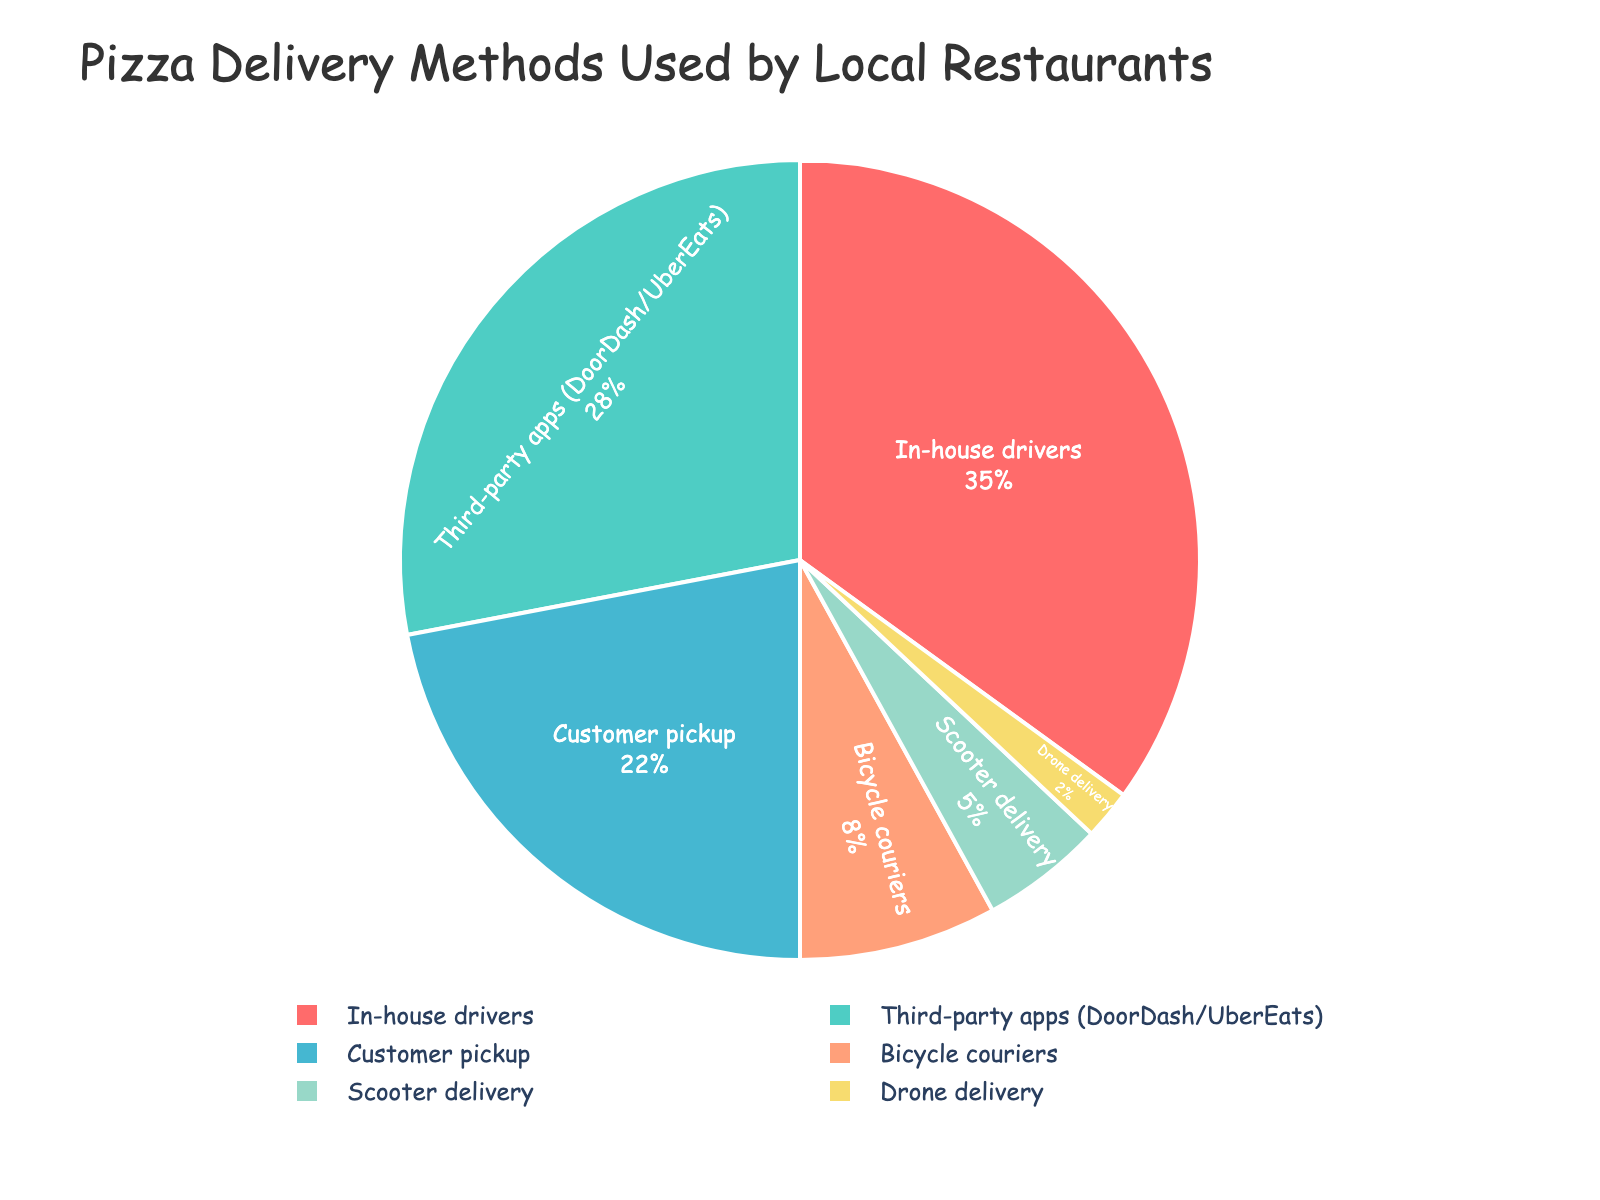What's the most common pizza delivery method? The pie chart shows that "In-house drivers" have the largest slice of the pie, indicating they are the most commonly used delivery method.
Answer: In-house drivers Which delivery method is used more: Bicycle couriers or Scooter delivery? The chart shows that Bicycle couriers make up 8% while Scooter delivery makes up 5% of the delivery methods. By comparing these percentages, it's clear that Bicycle couriers are used more.
Answer: Bicycle couriers What's the total percentage of delivery methods that do not involve motor vehicles? Non-motor vehicle methods include Bicycle couriers (8%), Customer pickup (22%), and Drone delivery (2%). Adding these percentages: 8 + 22 + 2 = 32.
Answer: 32% How much more popular are third-party apps compared to scooter delivery? Third-party apps make up 28% while Scooter delivery accounts for 5%. To find how much more popular third-party apps are, subtract these values: 28 - 5 = 23.
Answer: 23% What delivery method is represented by the yellow slice? The yellow slice of the pie chart corresponds to Drone delivery, which occupies 2% of the chart.
Answer: Drone delivery Which methods together make up more than half (over 50%) of the delivery methods? Adding the percentages of the most common methods: In-house drivers (35%) and Third-party apps (28%) results in 35 + 28 = 63, which is over 50%.
Answer: In-house drivers and Third-party apps What's the difference in percentage between the least common and the most common delivery methods? The least common delivery method is Drone delivery (2%), and the most common is In-house drivers (35%). The difference is 35 - 2 = 33.
Answer: 33% How many delivery methods have less than 10% usage? The chart shows that Bicycle couriers (8%), Scooter delivery (5%), and Drone delivery (2%) each have less than 10% usage. Counting these methods, there are 3.
Answer: 3 By what percentage is Customer pickup less popular than In-house drivers? Customer pickup is 22%, and In-house drivers are 35%. Subtracting these: 35 - 22 = 13.
Answer: 13% What percentage of restaurants use methods other than In-house drivers, Third-party apps, and Customer pickup? Methods other than the top three are Bicycle couriers (8%), Scooter delivery (5%), and Drone delivery (2%). Adding these: 8 + 5 + 2 = 15.
Answer: 15% 